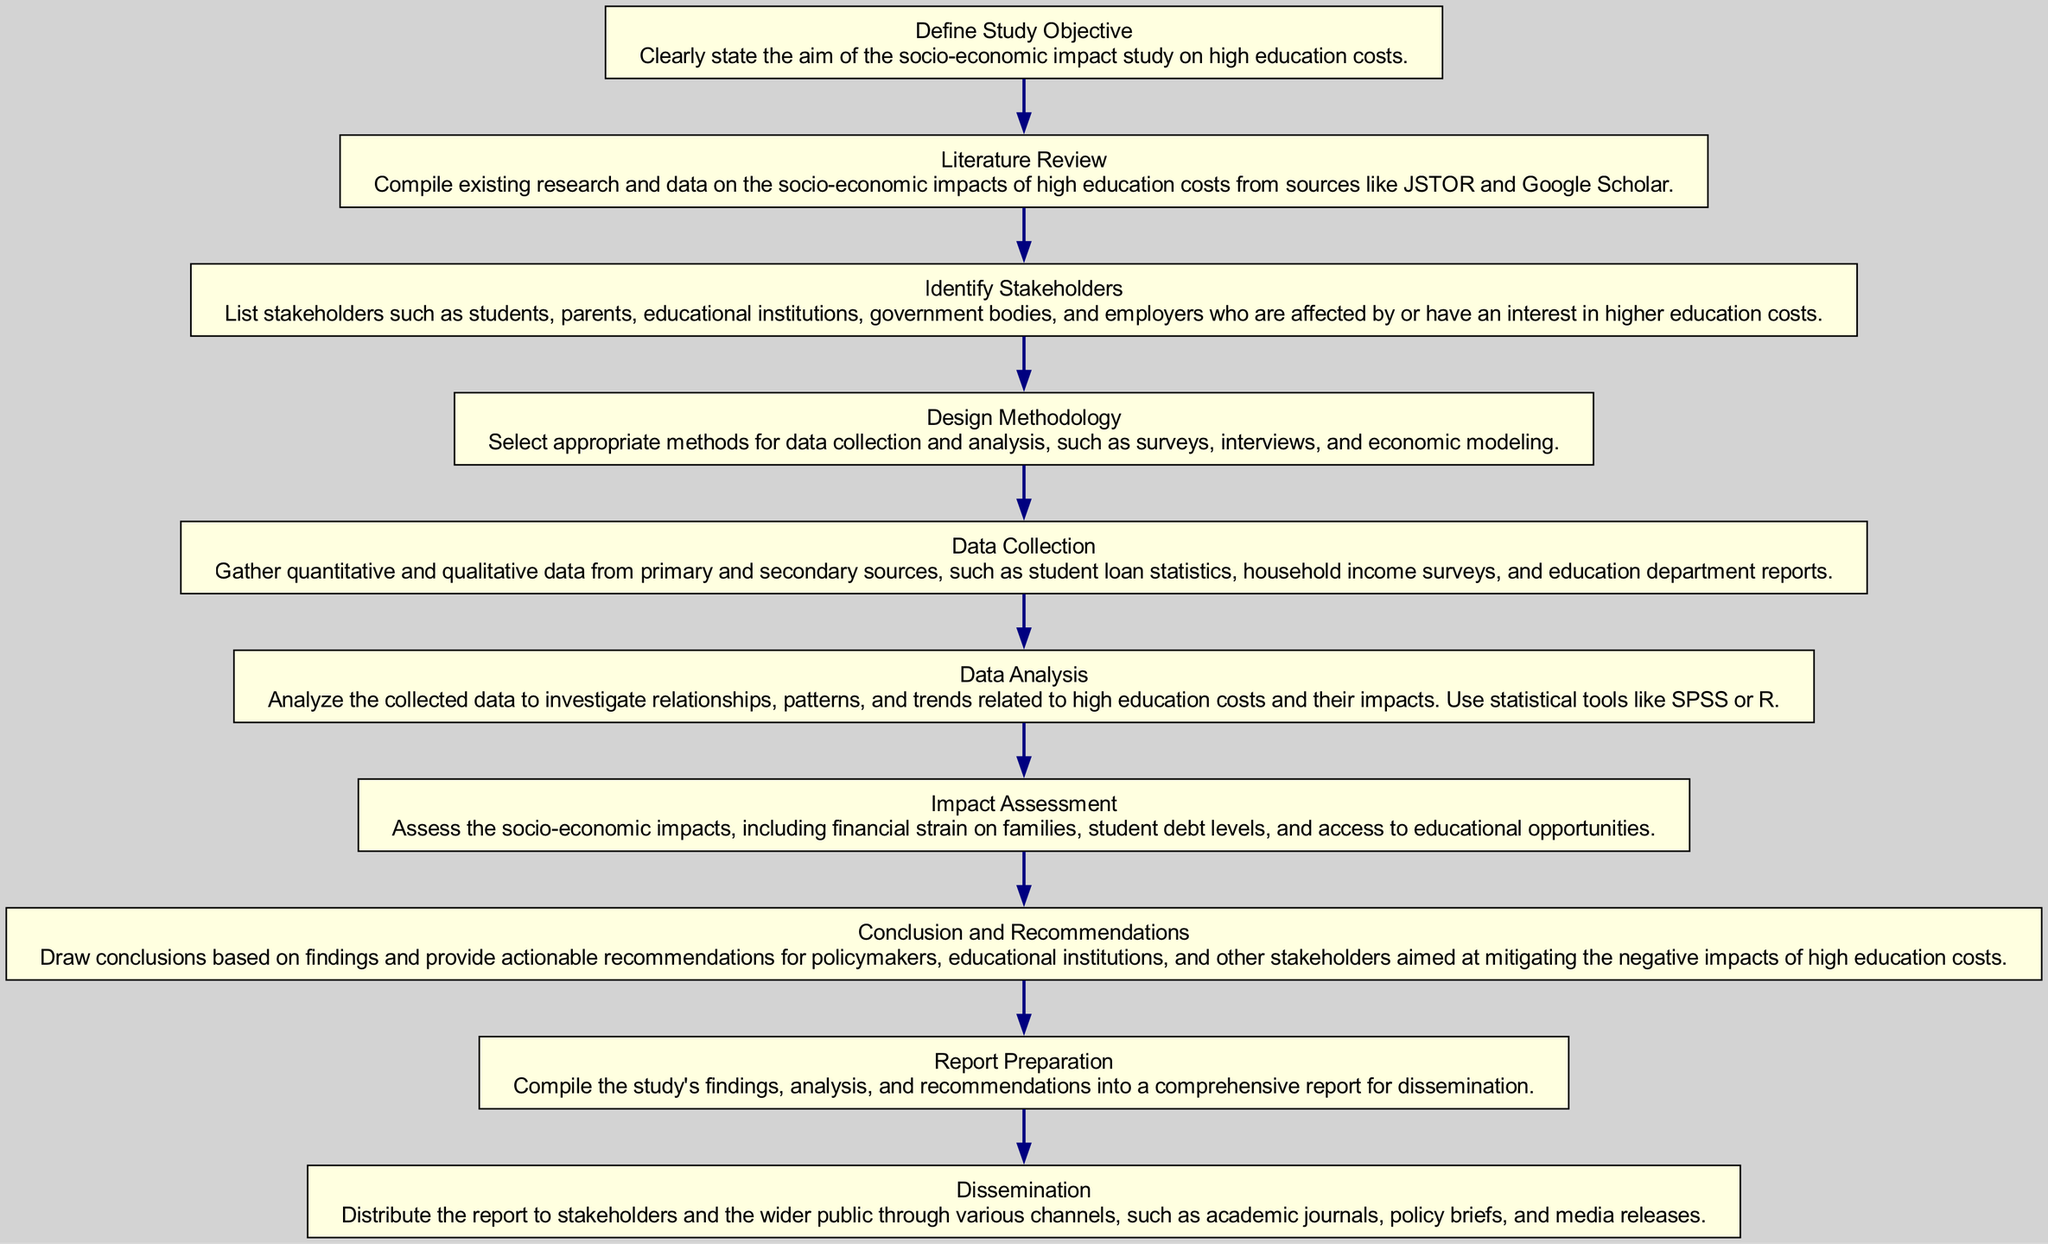What is the first step in the study procedure? The diagram begins with the node "Define Study Objective," which clearly states that the study's aim should be established first.
Answer: Define Study Objective How many total steps are there in the diagram? By counting the nodes listed in the diagram, we see there are ten distinct steps in the procedure.
Answer: 10 What is the last step in the process? The flowchart ends with the node "Dissemination," which indicates that the final action is to distribute the report to stakeholders.
Answer: Dissemination What step comes after "Data Collection"? Referring to the flow of the diagram, the step that follows "Data Collection" is "Data Analysis," where the gathered data is analyzed.
Answer: Data Analysis Which stakeholders are mentioned in the diagram? The "Identify Stakeholders" step lists students, parents, educational institutions, government bodies, and employers as affected or interested parties.
Answer: Students, parents, educational institutions, government bodies, employers What is the main purpose of the "Impact Assessment" step? This step is focused on assessing the socio-economic impacts related to high education costs, such as financial strain and student debt levels.
Answer: Assess the socio-economic impacts What is the sequence of steps from "Conclusion and Recommendations" to "Report Preparation"? The sequence follows from drawing conclusions, followed by compiling those findings, which are then prepared into a report. Hence, the flow is "Conclusion and Recommendations" leads into "Report Preparation."
Answer: Conclusion and Recommendations to Report Preparation In which step is literature compiled? The "Literature Review" step is where existing research and data are gathered to support the study.
Answer: Literature Review What is the focus of the "Design Methodology" step? This step involves selecting data collection methods, such as surveys and interviews, essential for the study's structure.
Answer: Selecting methods for data collection and analysis 